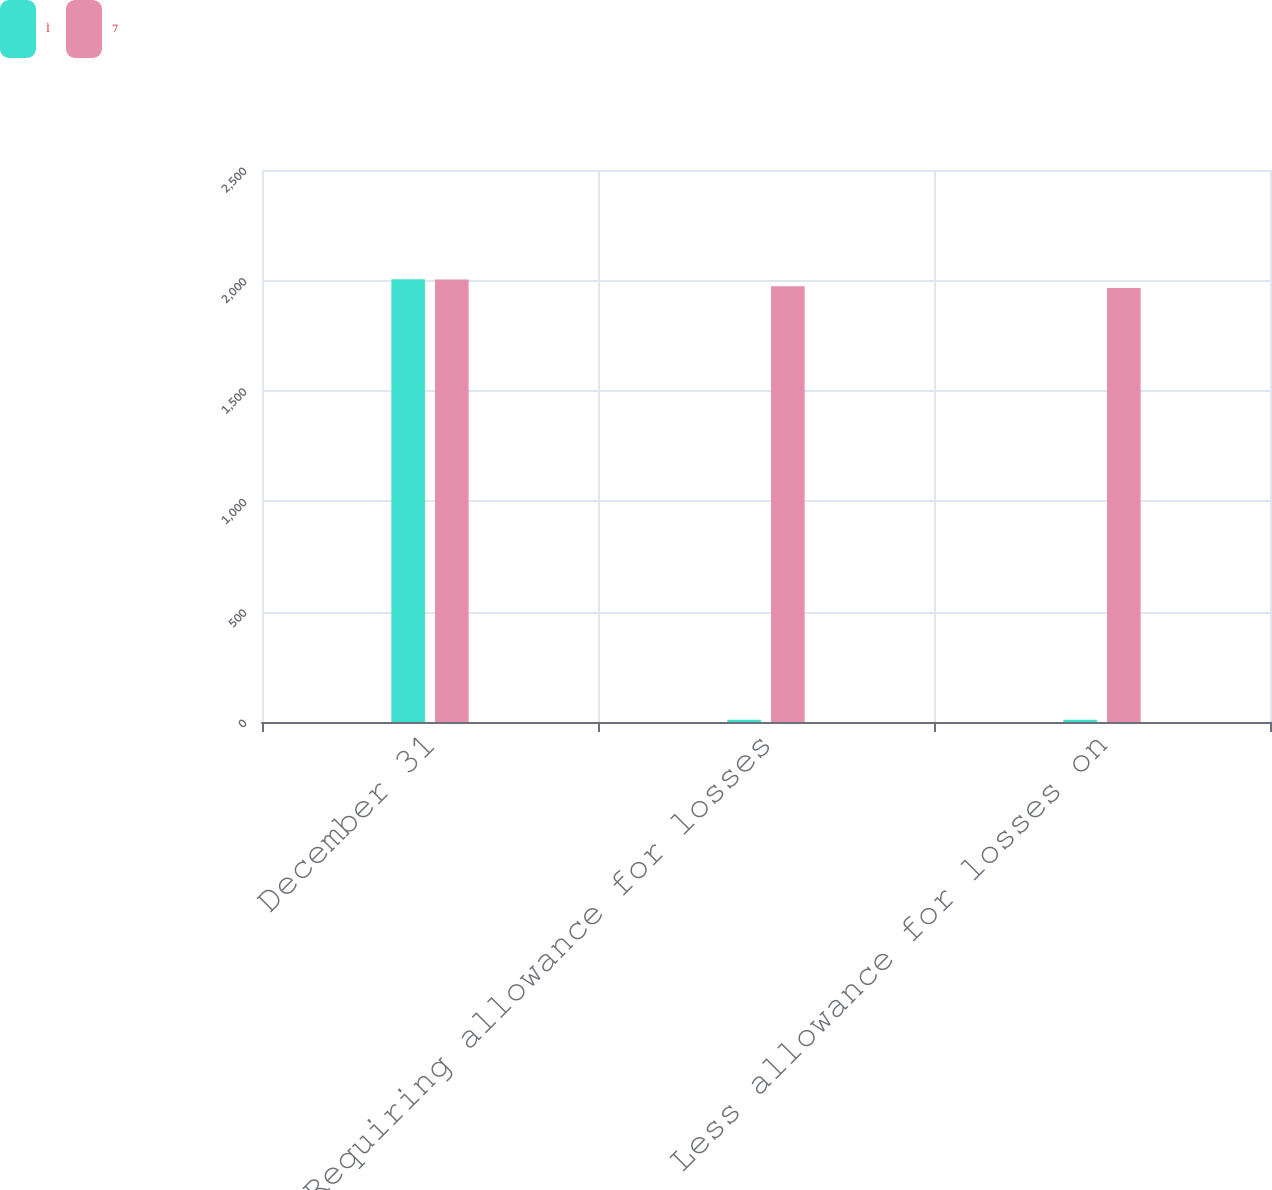Convert chart to OTSL. <chart><loc_0><loc_0><loc_500><loc_500><stacked_bar_chart><ecel><fcel>December 31<fcel>Requiring allowance for losses<fcel>Less allowance for losses on<nl><fcel>Ì<fcel>2005<fcel>10<fcel>10<nl><fcel>7<fcel>2004<fcel>1973<fcel>1966<nl></chart> 